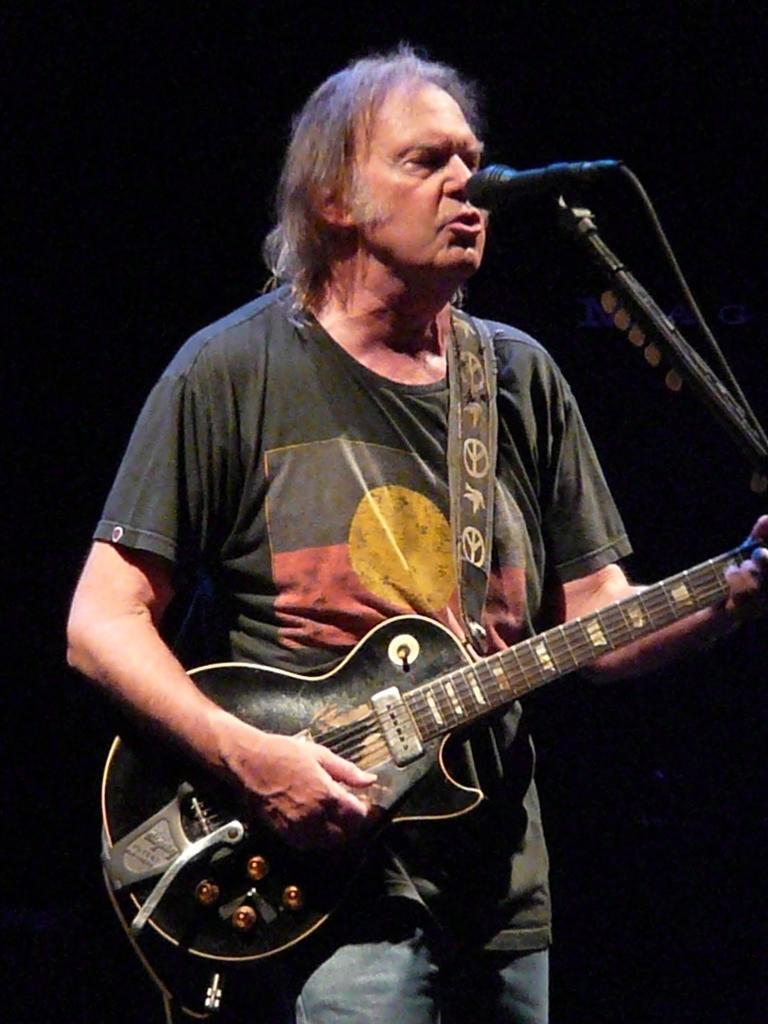Can you describe this image briefly? In this picture there is a man who is standing in the center of the image, by holding a guitar in his hands and there is a mic in front of him. 